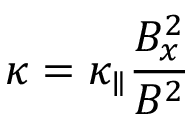Convert formula to latex. <formula><loc_0><loc_0><loc_500><loc_500>\kappa = \kappa _ { \| } \frac { B _ { x } ^ { 2 } } { B ^ { 2 } }</formula> 